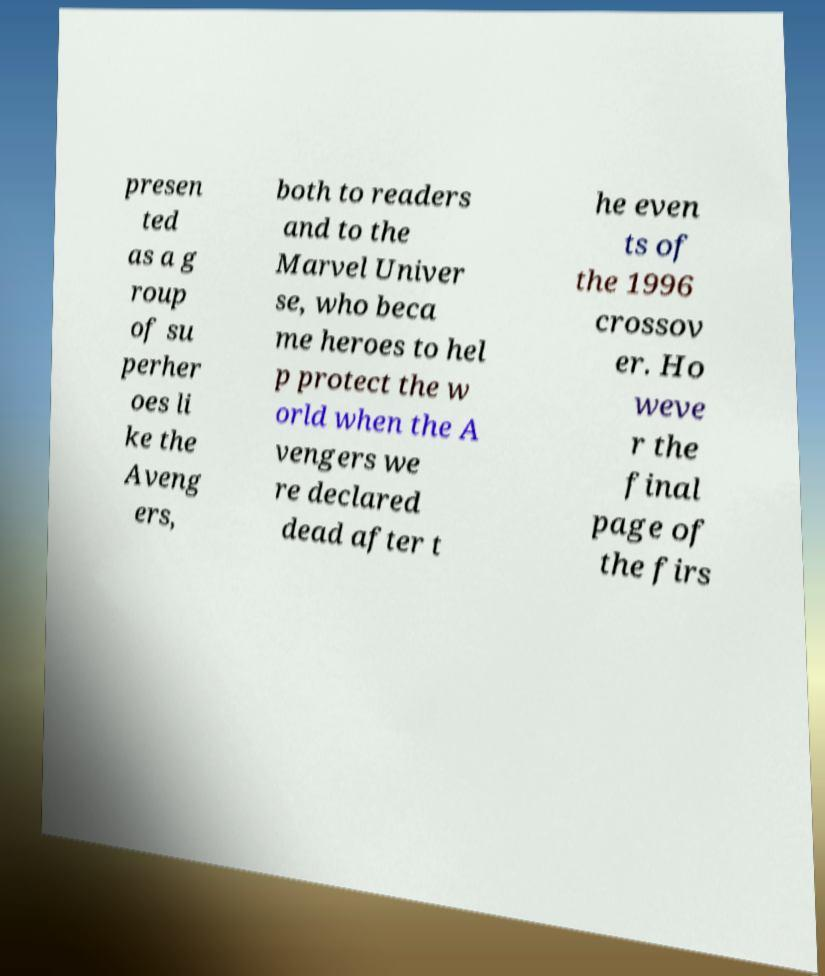For documentation purposes, I need the text within this image transcribed. Could you provide that? presen ted as a g roup of su perher oes li ke the Aveng ers, both to readers and to the Marvel Univer se, who beca me heroes to hel p protect the w orld when the A vengers we re declared dead after t he even ts of the 1996 crossov er. Ho weve r the final page of the firs 